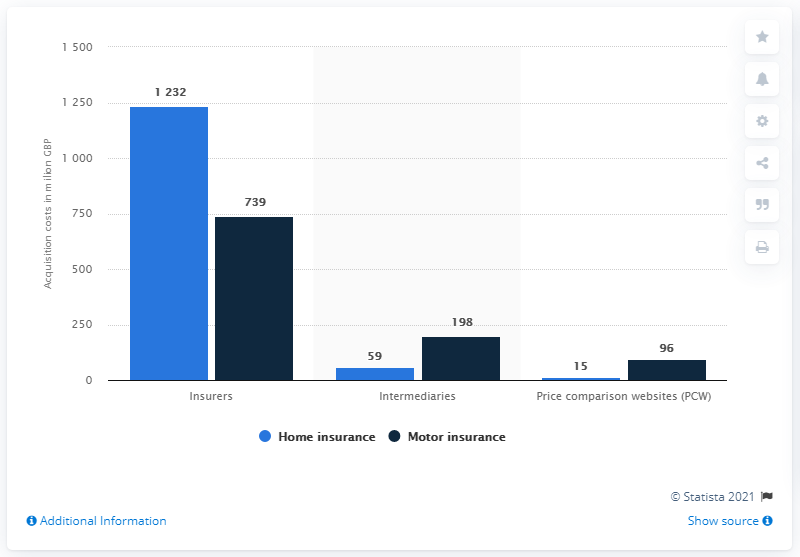Specify some key components in this picture. In 2018, home insurance companies spent a total of $123,232 on acquiring premiums. How much did price comparison websites spend on home insurance acquisition costs in 2018? In total, approximately 15% of their budget was dedicated to acquiring new customers. 